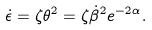<formula> <loc_0><loc_0><loc_500><loc_500>\dot { \epsilon } = \zeta \theta ^ { 2 } = \zeta \dot { \beta } ^ { 2 } e ^ { - 2 \alpha } .</formula> 